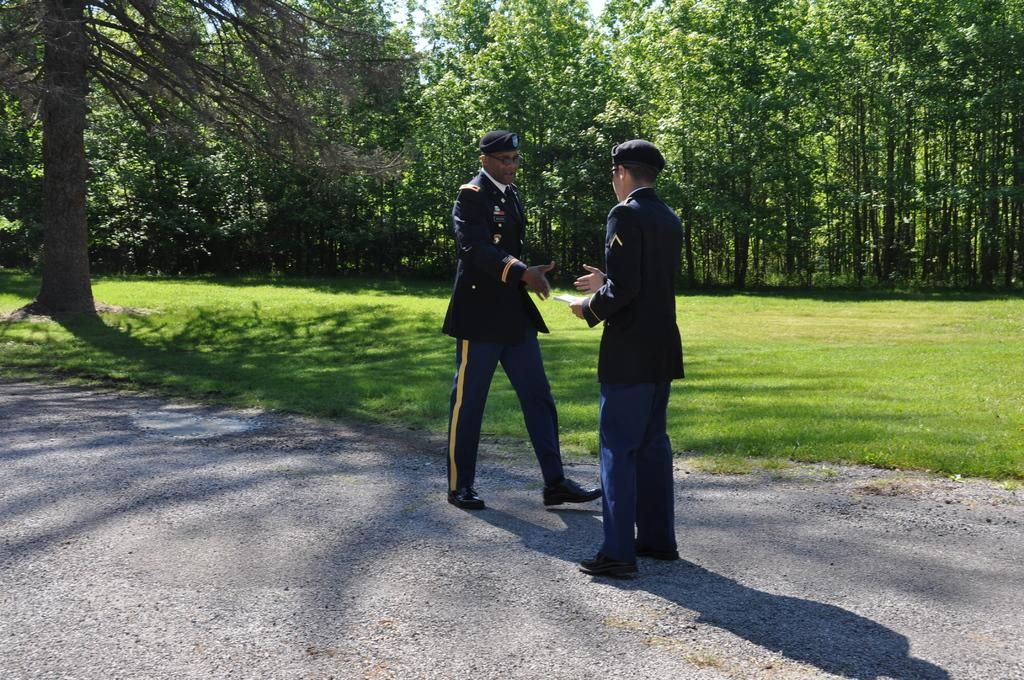How many officers are present in the image? There are two officers in the image. What are the officers doing in the image? The officers are shaking hands. What can be seen in the background of the image? There are trees on a grassland in the background of the image. Are there any slaves visible in the image? There is no reference to any slaves in the image; it features two officers shaking hands. How many spiders can be seen crawling on the officers in the image? There are no spiders present in the image. 